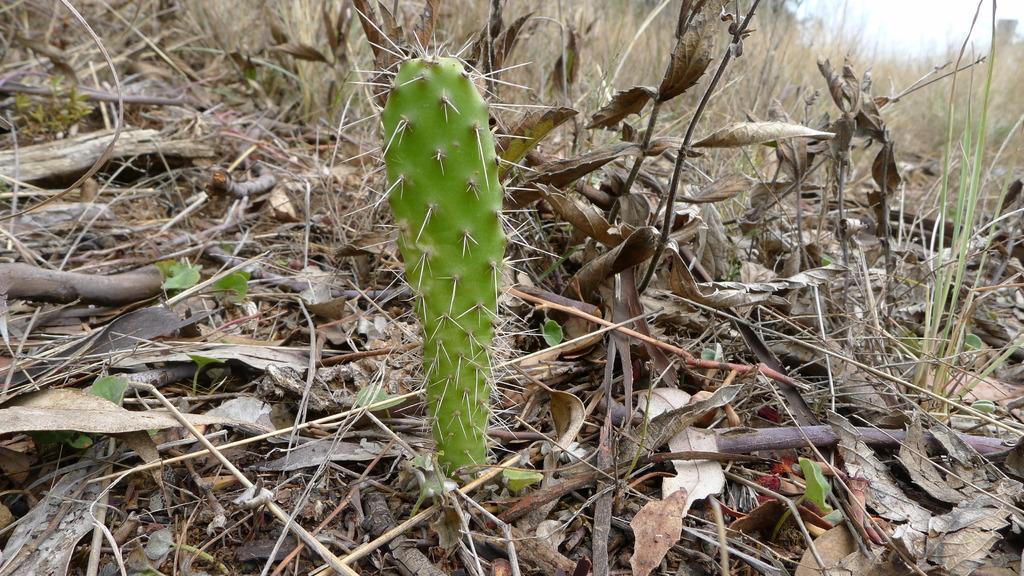Please provide a concise description of this image. IN this image, we can see a cactus, few dry leaves, grass, some plants, sticks. 